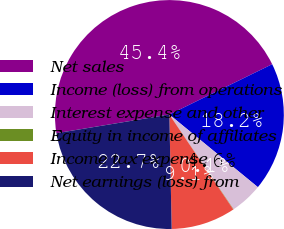Convert chart to OTSL. <chart><loc_0><loc_0><loc_500><loc_500><pie_chart><fcel>Net sales<fcel>Income (loss) from operations<fcel>Interest expense and other<fcel>Equity in income of affiliates<fcel>Income tax expense<fcel>Net earnings (loss) from<nl><fcel>45.36%<fcel>18.18%<fcel>4.58%<fcel>0.05%<fcel>9.11%<fcel>22.71%<nl></chart> 